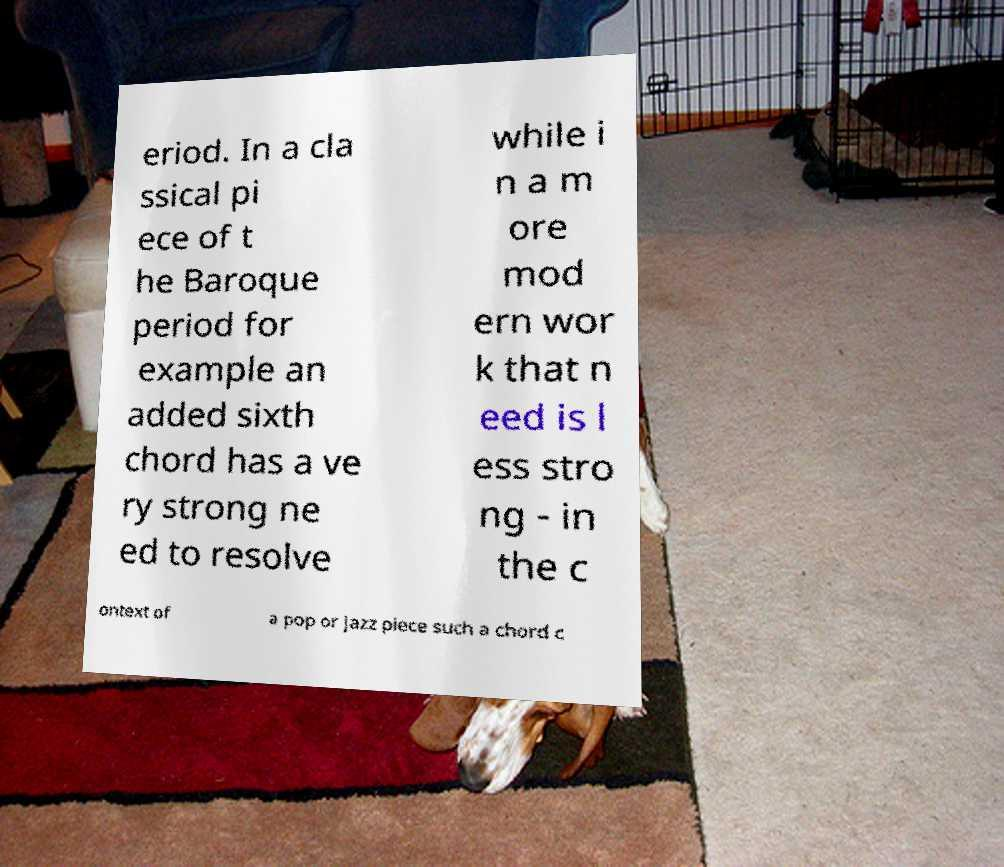There's text embedded in this image that I need extracted. Can you transcribe it verbatim? eriod. In a cla ssical pi ece of t he Baroque period for example an added sixth chord has a ve ry strong ne ed to resolve while i n a m ore mod ern wor k that n eed is l ess stro ng - in the c ontext of a pop or jazz piece such a chord c 